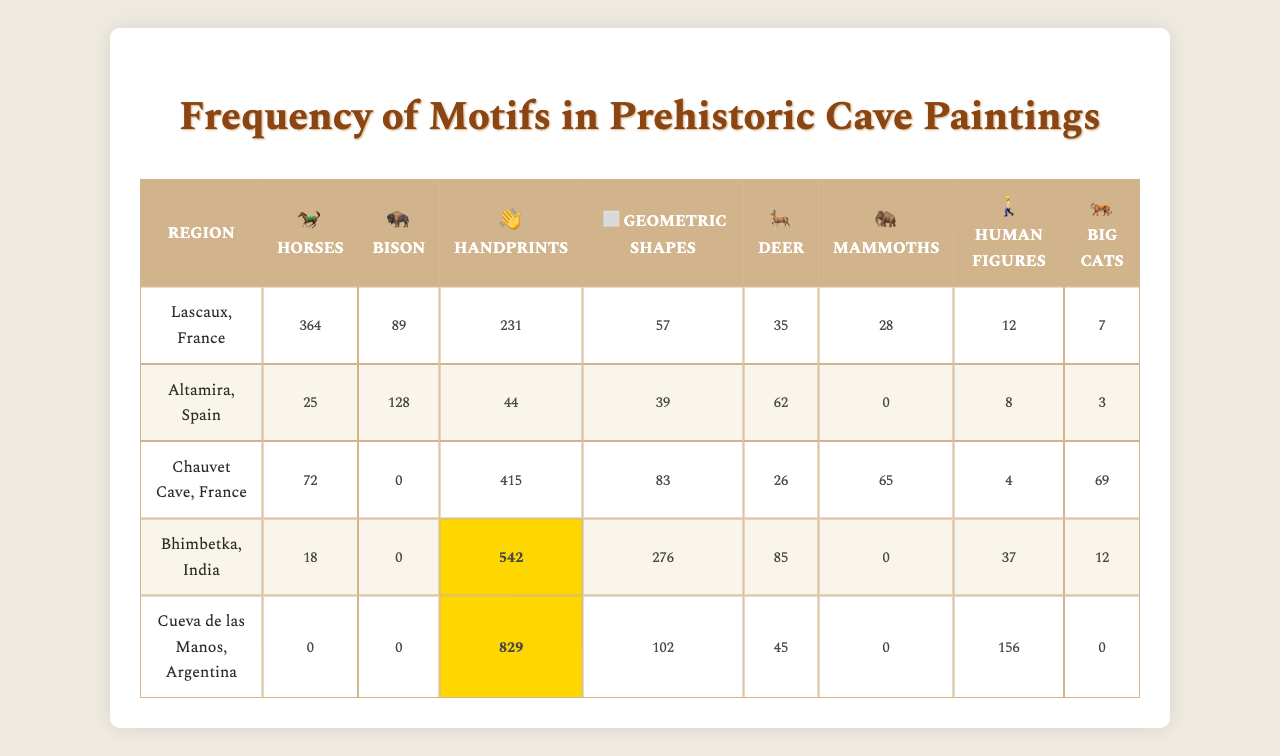What is the highest frequency motif in the Bhimbetka, India region? The highest frequency motif in Bhimbetka, India is "Handprints," with a frequency of 542.
Answer: Handprints Which region features the motif of "Bison" the most? The region that features "Bison" the most is Altamira, Spain, with a frequency of 128.
Answer: Altamira, Spain How many "Horses" are depicted in the Lascaux, France cave paintings? Lascaux, France has a total of 364 "Horses" depicted in its cave paintings.
Answer: 364 Is it true that "Mammoths" were depicted in more caves than "Big cats"? In the table, "Mammoths" are found in two regions (Bhimbetka and Lascaux) while "Big cats" are found in one (Chauvet). Therefore, it is true that "Mammoths" have a wider depiction.
Answer: Yes What is the combined frequency of "Geometric shapes" for all the regions listed? The combined frequency of "Geometric shapes" is calculated: 57 (Lascaux) + 39 (Altamira) + 83 (Chauvet) + 276 (Bhimbetka) + 102 (Cueva de las Manos) = 557.
Answer: 557 Which region has the lowest frequency for the motif "Deer"? The region with the lowest frequency for "Deer" is Chauvet Cave, France, which has a frequency of 26.
Answer: Chauvet Cave, France What is the average frequency of "Human figures" across all regions? The frequencies of "Human figures" are 12 (Lascaux) + 8 (Altamira) + 4 (Chauvet) + 37 (Bhimbetka) + 156 (Cueva de las Manos). The sum is 217, and with 5 regions, the average is 217/5 = 43.4.
Answer: 43.4 In which region is the frequency of "Bison" highest compared to other motifs available in that region? In Altamira, Spain, "Bison" is the most depicted motif with a frequency of 128, higher than other motifs in that region.
Answer: Altamira, Spain Which regions have more than 500 counts for any motif? The regions with more than 500 counts are Bhimbetka, India for "Handprints" (542) and Cueva de las Manos, Argentina for "Handprints" (829).
Answer: Bhimbetka, India and Cueva de las Manos, Argentina If we were to remove the motifs that have zero counts from the table, how many unique motifs would remain visible in the Altamira region? In Altamira, the motifs with zero counts are "Mammoths" (0) and do not affect the overall count of unique motifs because it has 8 total motifs, leaving 7 unique motifs visible.
Answer: 7 